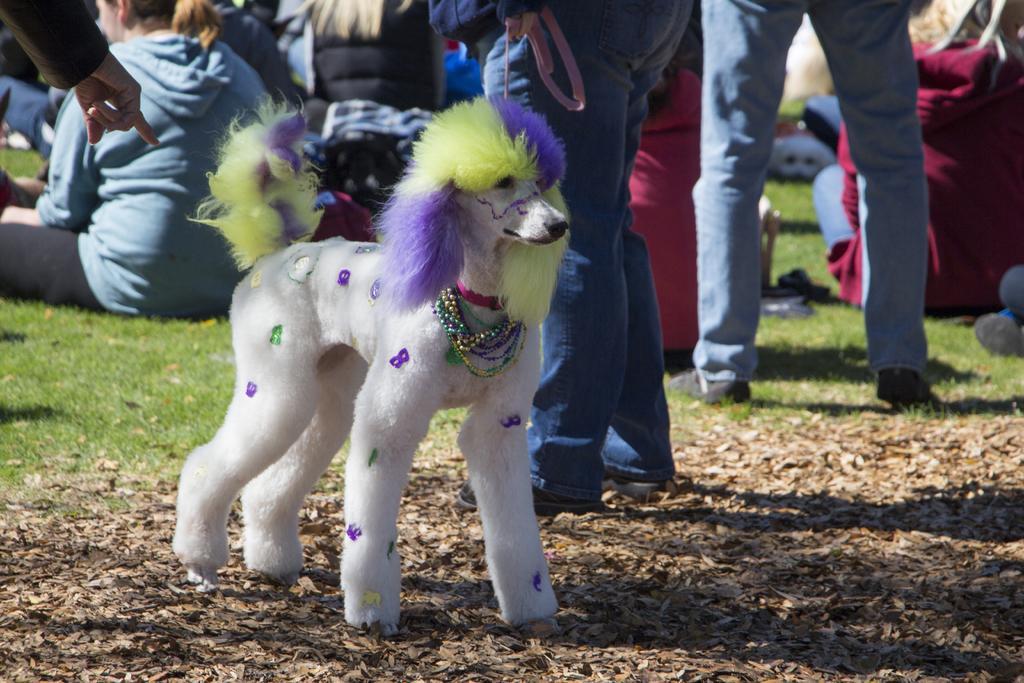How would you summarize this image in a sentence or two? In this image, there are a few people. We can see a dog. We can see the ground covered with grass, dried leaves and some objects. 